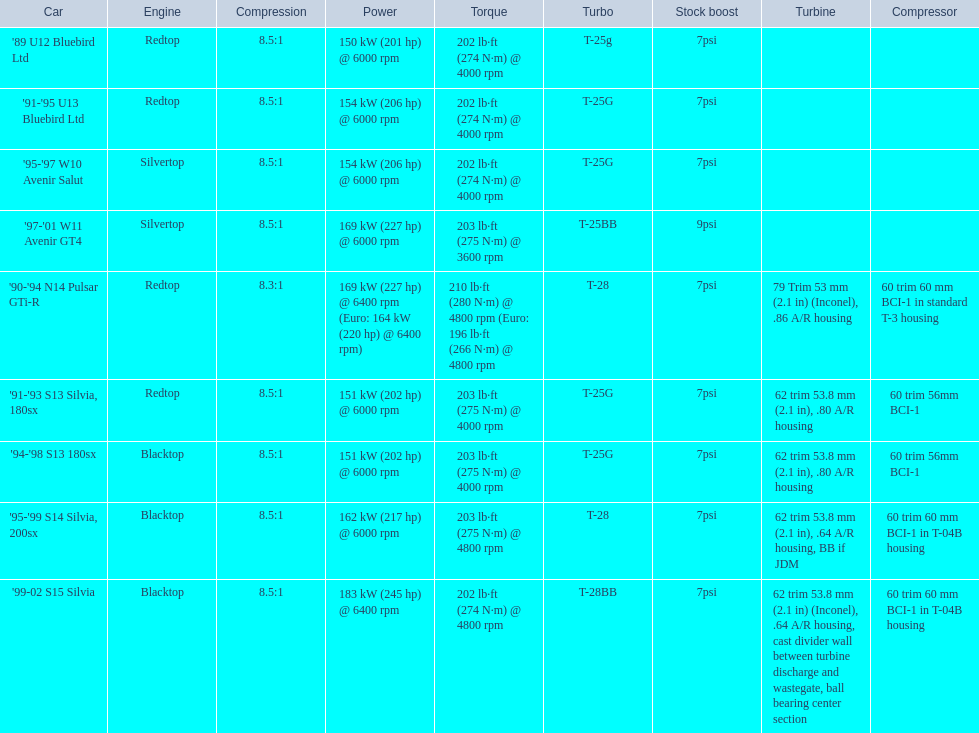Which cars featured blacktop engines? '94-'98 S13 180sx, '95-'99 S14 Silvia, 200sx, '99-02 S15 Silvia. Which of these had t-04b compressor housings? '95-'99 S14 Silvia, 200sx, '99-02 S15 Silvia. Which one of these has the highest horsepower? '99-02 S15 Silvia. 